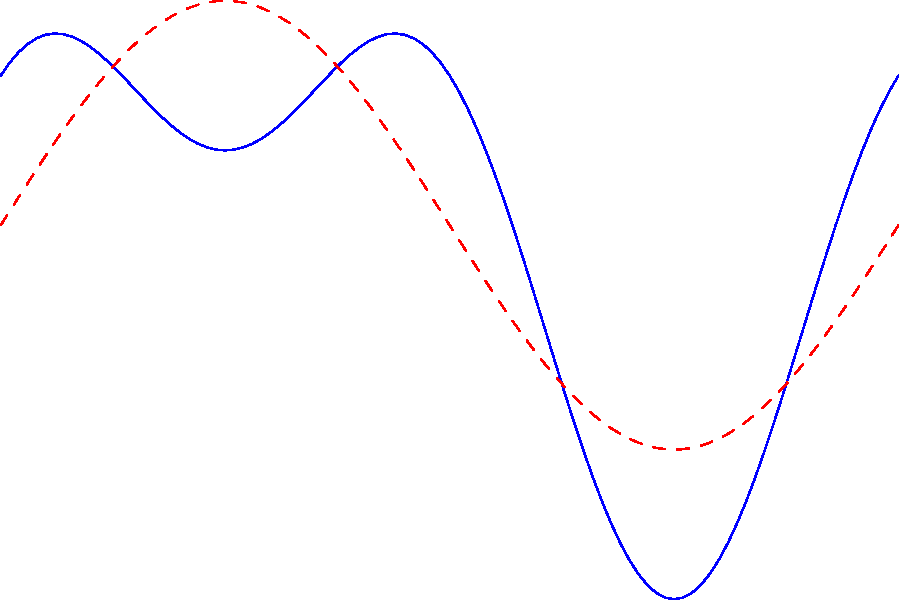In a romantic film, the emotional intensity over its 12-hour duration is modeled by the function $f(x) = 5 + 3\sin(\frac{\pi x}{6}) + 2\cos(\frac{\pi x}{3})$, where $x$ is the time in hours and $f(x)$ is the emotional intensity. The red dashed line represents only the sine component. At what time(s) during the film does the cosine component contribute most significantly to the overall emotional intensity, and what is the maximum contribution of the cosine component? To solve this problem, we need to follow these steps:

1) The cosine component's contribution is most significant when its absolute value is at its maximum.

2) The cosine term in the function is $2\cos(\frac{\pi x}{3})$. Its maximum value occurs when $\frac{\pi x}{3} = 0, 2\pi, 4\pi, ...$, and its minimum (negative maximum) occurs when $\frac{\pi x}{3} = \pi, 3\pi, 5\pi, ...$

3) Solving for x:
   For maximum: $\frac{\pi x}{3} = 0, 2\pi, 4\pi, ...$
   $x = 0, 6, 12, ...$

   For minimum: $\frac{\pi x}{3} = \pi, 3\pi, 5\pi, ...$
   $x = 3, 9, 15, ...$

4) Within the 12-hour duration, the cosine component reaches its maximum contribution at 0, 6, and 12 hours, and its minimum at 3 and 9 hours.

5) The maximum contribution of the cosine component is the amplitude of $2\cos(\frac{\pi x}{3})$, which is 2.

Therefore, the cosine component contributes most significantly at 0, 3, 6, 9, and 12 hours, with a maximum contribution of 2 to the overall emotional intensity.
Answer: 0, 3, 6, 9, and 12 hours; maximum contribution of 2 